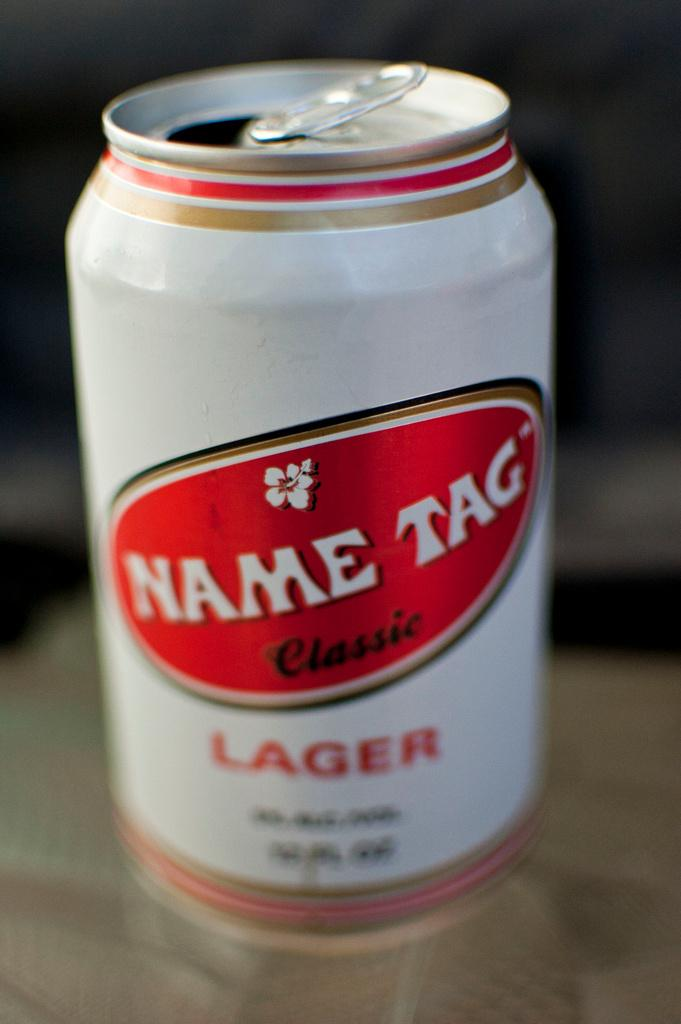What is the color of the tin in the image? The tin in the image is white. Where is the tin located in the image? The tin is placed on a surface. What type of animal can be seen playing chess on the channel in the image? There is no animal or chess game present in the image. The image only features a white tin placed on a surface. 